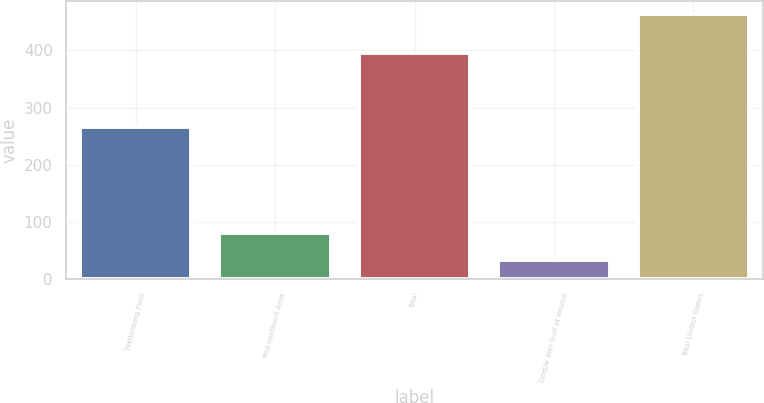<chart> <loc_0><loc_0><loc_500><loc_500><bar_chart><fcel>Wattenberg Field<fcel>Mid-continent Area<fcel>Total<fcel>Deepw ater Gulf of Mexico<fcel>Total United States<nl><fcel>266<fcel>80<fcel>395<fcel>34<fcel>464<nl></chart> 